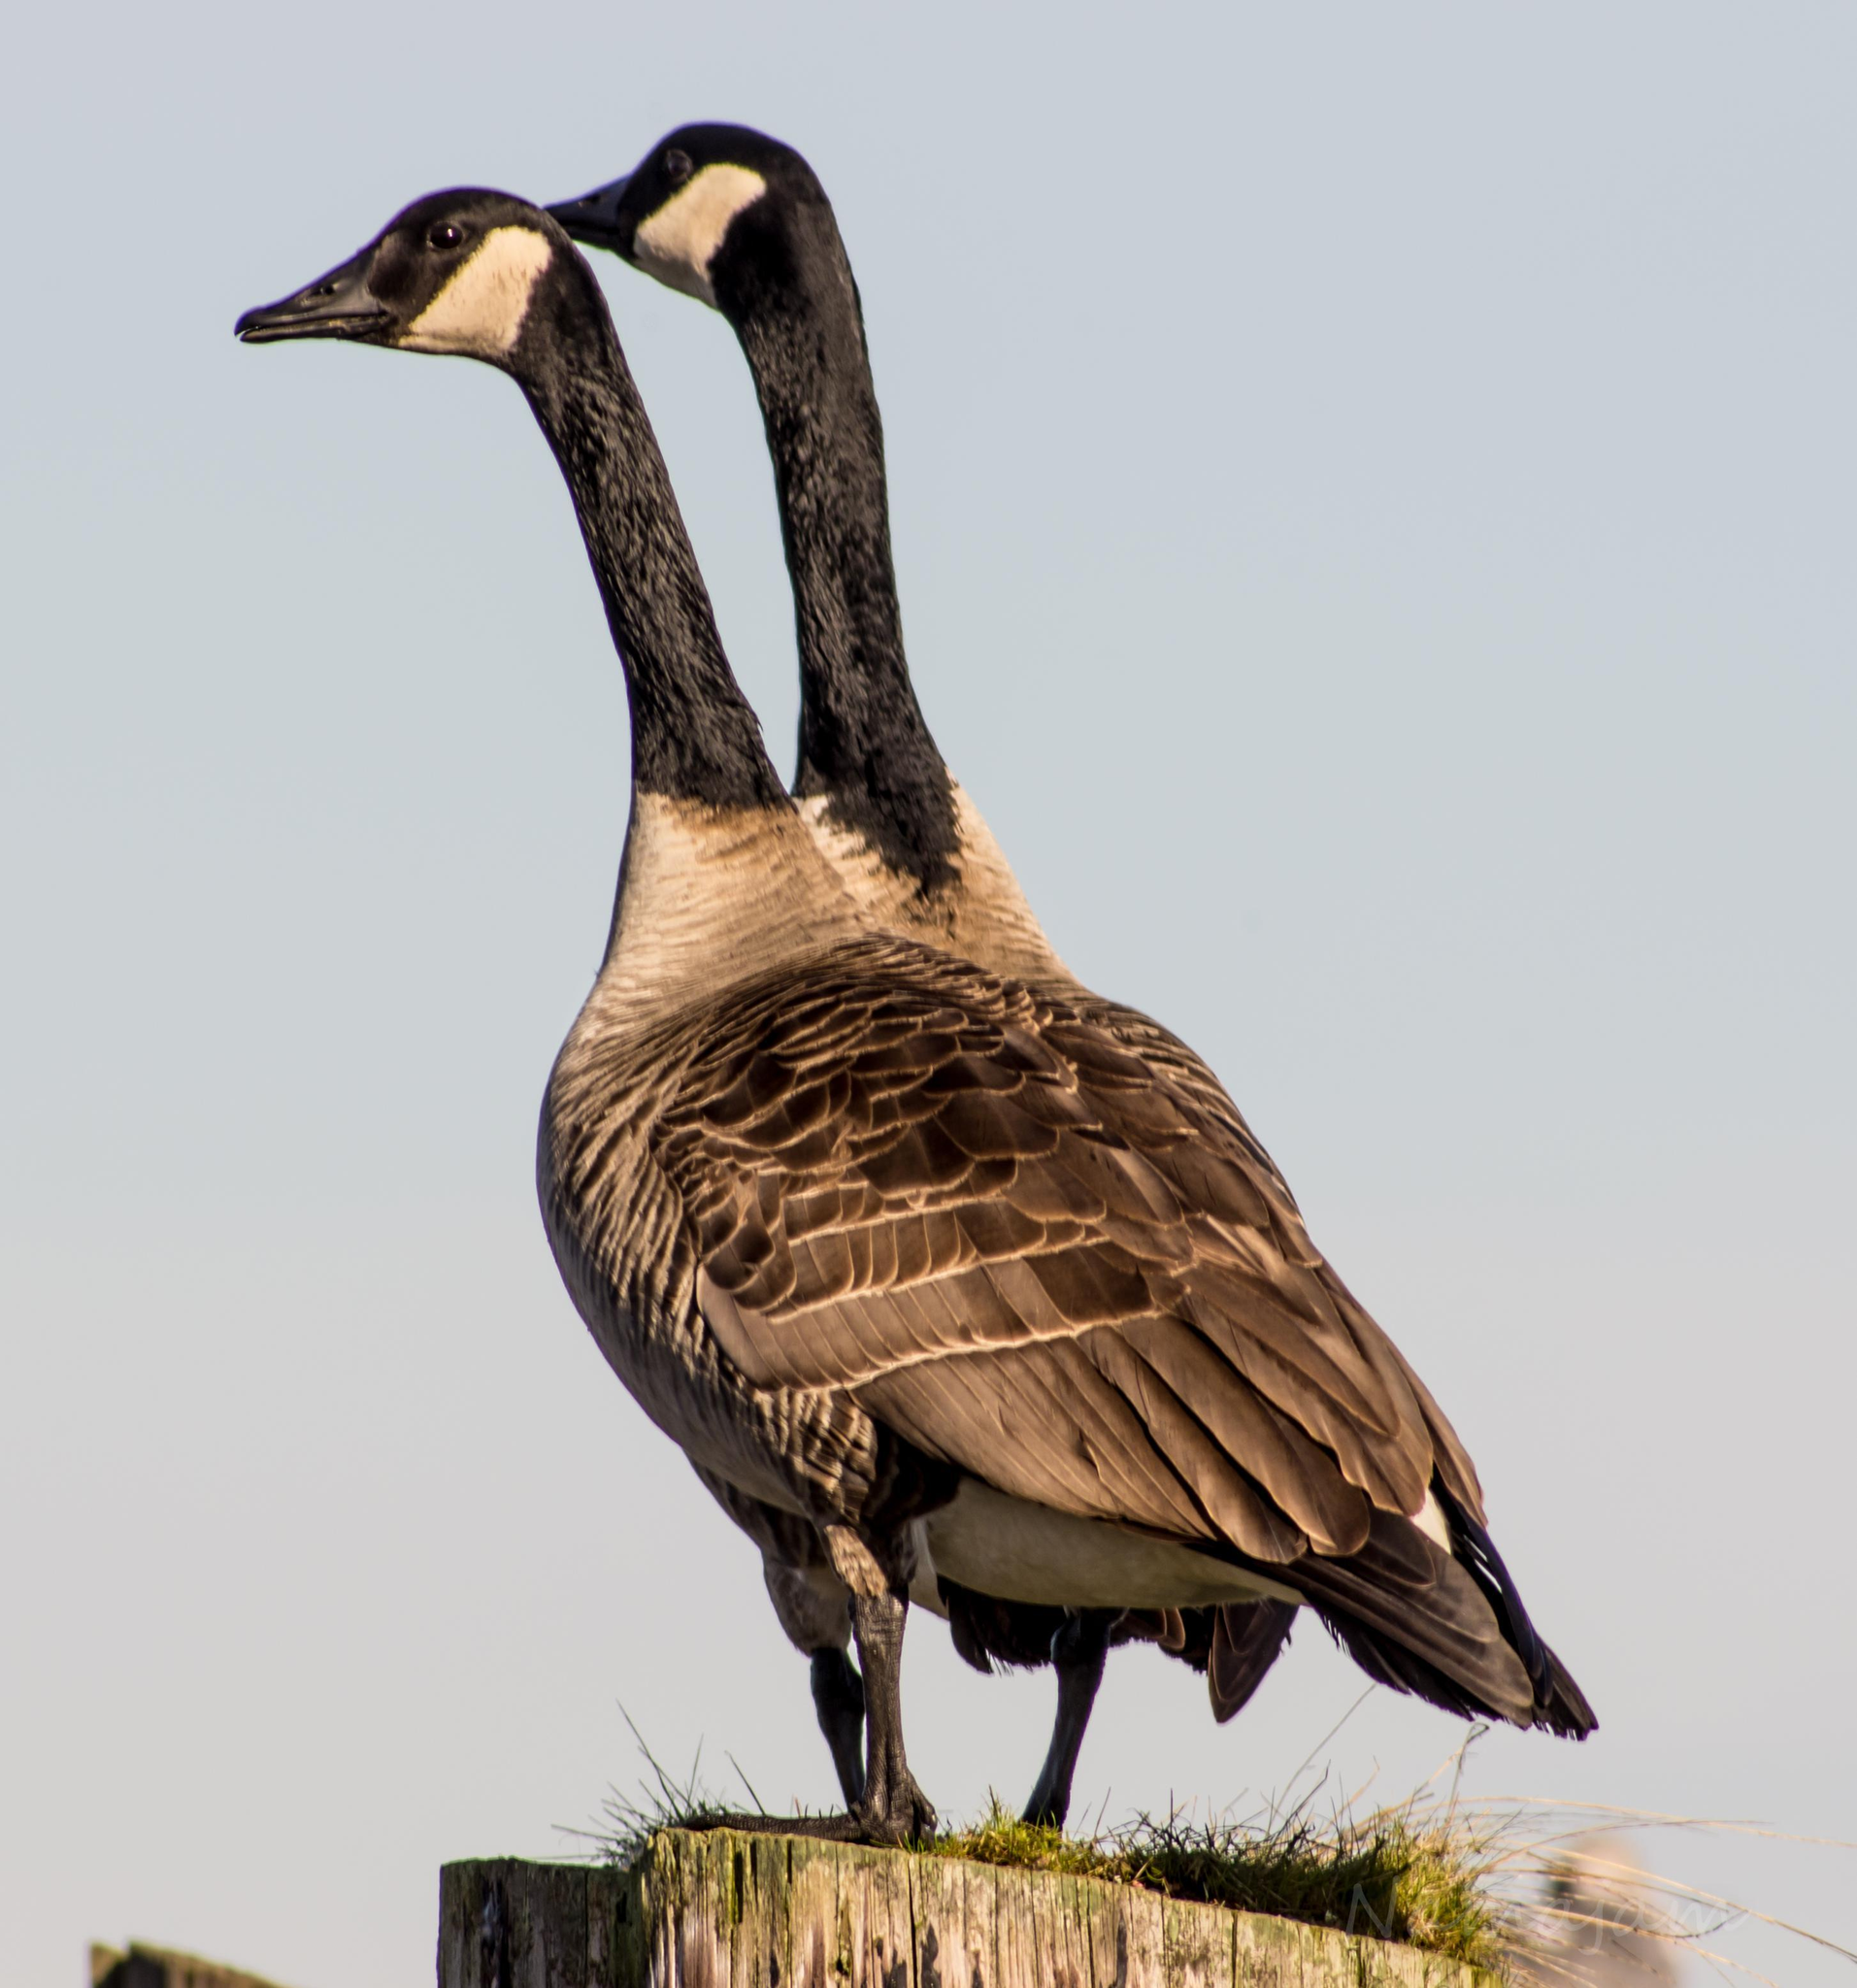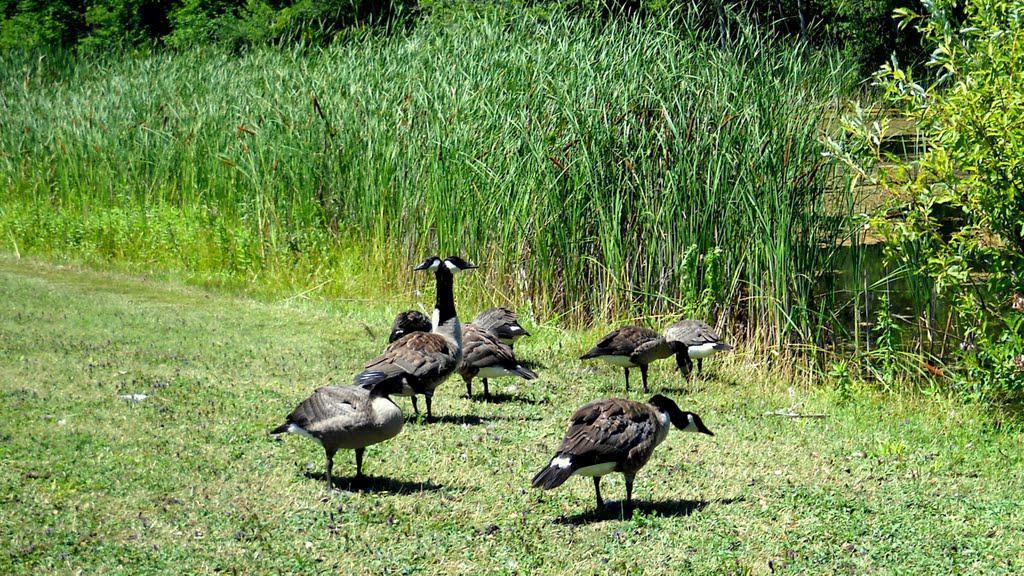The first image is the image on the left, the second image is the image on the right. Analyze the images presented: Is the assertion "The left image shows two geese standing with bodies overlapping and upright heads close together and facing left." valid? Answer yes or no. Yes. The first image is the image on the left, the second image is the image on the right. Assess this claim about the two images: "there are 2 geese with black and white heads standing on the grass with their shadow next to them". Correct or not? Answer yes or no. No. 